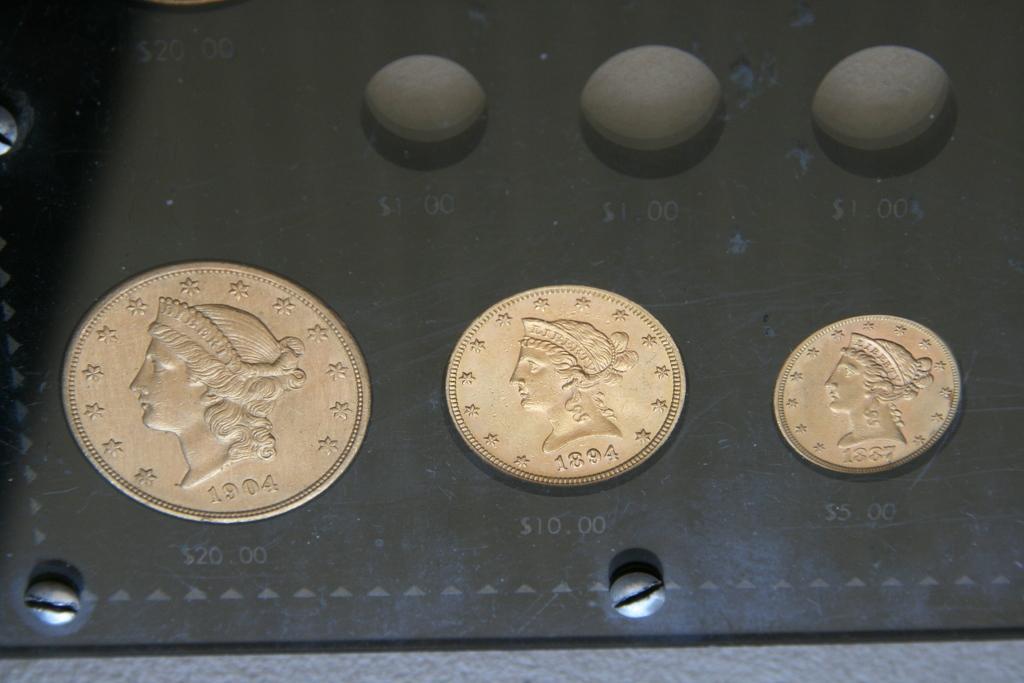Please provide a concise description of this image. In this image in the center there are coins with numbers and image on it and at the top there are objects which are black in colour. 